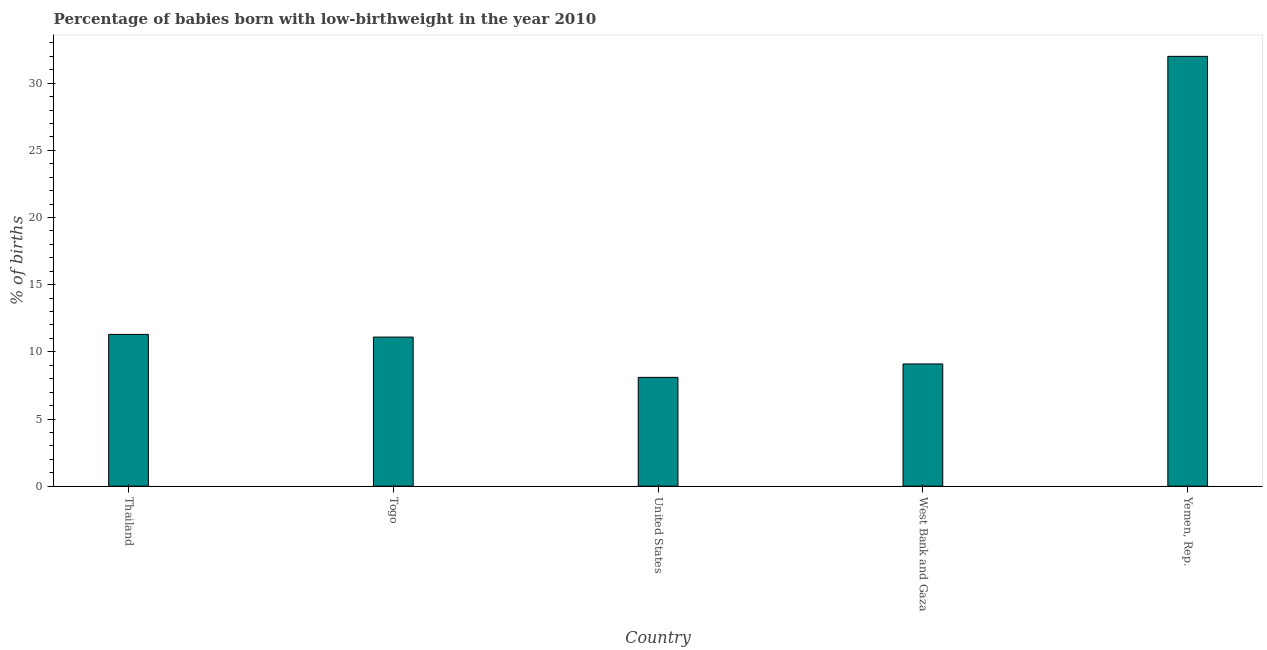Does the graph contain grids?
Provide a short and direct response. No. What is the title of the graph?
Give a very brief answer. Percentage of babies born with low-birthweight in the year 2010. What is the label or title of the X-axis?
Provide a short and direct response. Country. What is the label or title of the Y-axis?
Offer a very short reply. % of births. What is the percentage of babies who were born with low-birthweight in United States?
Give a very brief answer. 8.1. Across all countries, what is the minimum percentage of babies who were born with low-birthweight?
Provide a succinct answer. 8.1. In which country was the percentage of babies who were born with low-birthweight maximum?
Ensure brevity in your answer.  Yemen, Rep. In which country was the percentage of babies who were born with low-birthweight minimum?
Provide a short and direct response. United States. What is the sum of the percentage of babies who were born with low-birthweight?
Make the answer very short. 71.6. What is the difference between the percentage of babies who were born with low-birthweight in Togo and United States?
Keep it short and to the point. 3. What is the average percentage of babies who were born with low-birthweight per country?
Offer a terse response. 14.32. In how many countries, is the percentage of babies who were born with low-birthweight greater than 11 %?
Your response must be concise. 3. What is the ratio of the percentage of babies who were born with low-birthweight in Thailand to that in Togo?
Give a very brief answer. 1.02. Is the percentage of babies who were born with low-birthweight in West Bank and Gaza less than that in Yemen, Rep.?
Your response must be concise. Yes. What is the difference between the highest and the second highest percentage of babies who were born with low-birthweight?
Ensure brevity in your answer.  20.7. What is the difference between the highest and the lowest percentage of babies who were born with low-birthweight?
Your answer should be compact. 23.9. What is the difference between two consecutive major ticks on the Y-axis?
Provide a succinct answer. 5. Are the values on the major ticks of Y-axis written in scientific E-notation?
Your answer should be compact. No. What is the % of births in Thailand?
Offer a very short reply. 11.3. What is the % of births of United States?
Your answer should be very brief. 8.1. What is the % of births in West Bank and Gaza?
Provide a short and direct response. 9.1. What is the % of births in Yemen, Rep.?
Ensure brevity in your answer.  32. What is the difference between the % of births in Thailand and Togo?
Ensure brevity in your answer.  0.2. What is the difference between the % of births in Thailand and West Bank and Gaza?
Offer a very short reply. 2.2. What is the difference between the % of births in Thailand and Yemen, Rep.?
Ensure brevity in your answer.  -20.7. What is the difference between the % of births in Togo and Yemen, Rep.?
Offer a very short reply. -20.9. What is the difference between the % of births in United States and Yemen, Rep.?
Your answer should be compact. -23.9. What is the difference between the % of births in West Bank and Gaza and Yemen, Rep.?
Offer a terse response. -22.9. What is the ratio of the % of births in Thailand to that in Togo?
Make the answer very short. 1.02. What is the ratio of the % of births in Thailand to that in United States?
Your response must be concise. 1.4. What is the ratio of the % of births in Thailand to that in West Bank and Gaza?
Your answer should be compact. 1.24. What is the ratio of the % of births in Thailand to that in Yemen, Rep.?
Give a very brief answer. 0.35. What is the ratio of the % of births in Togo to that in United States?
Offer a very short reply. 1.37. What is the ratio of the % of births in Togo to that in West Bank and Gaza?
Make the answer very short. 1.22. What is the ratio of the % of births in Togo to that in Yemen, Rep.?
Your answer should be compact. 0.35. What is the ratio of the % of births in United States to that in West Bank and Gaza?
Your answer should be compact. 0.89. What is the ratio of the % of births in United States to that in Yemen, Rep.?
Ensure brevity in your answer.  0.25. What is the ratio of the % of births in West Bank and Gaza to that in Yemen, Rep.?
Your response must be concise. 0.28. 